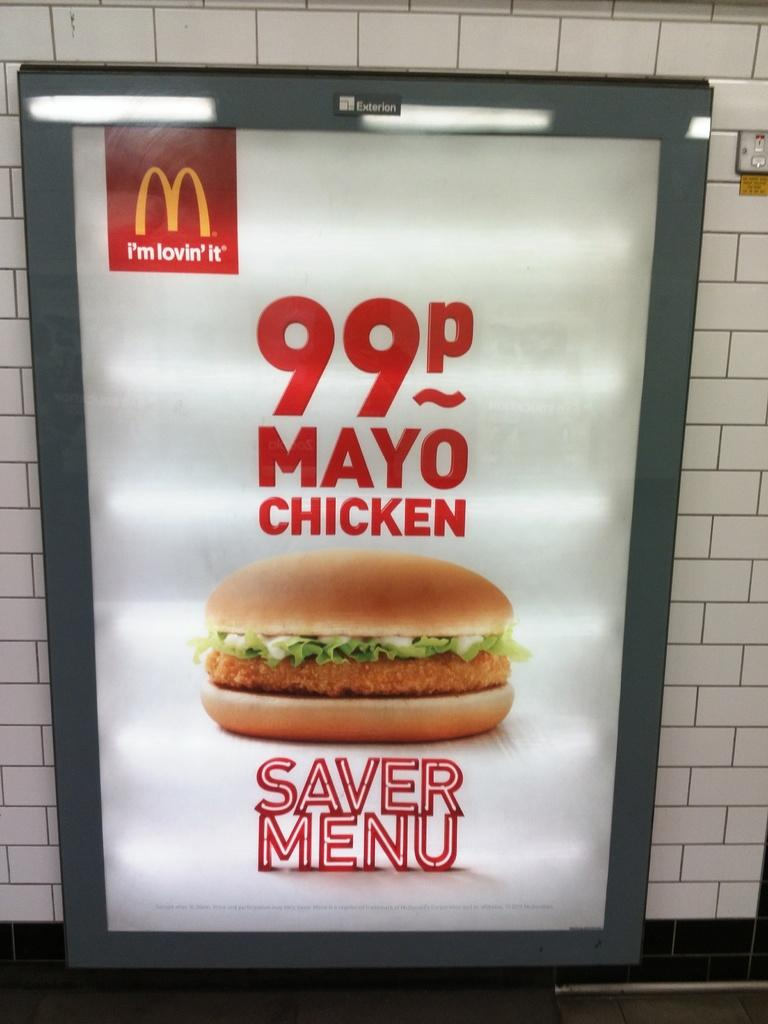What is on the tile wall in the image? There is a hoarding on the tile wall in the image. What is depicted in the picture on the hoarding? The hoarding contains a picture of a burger. What can be seen on the hoarding besides the picture of the burger? There are lights visible on the hoarding, as well as a logo and text. What type of wood is used to make the burger in the image? There is no wood present in the image, and the burger is a picture, not an actual burger. 